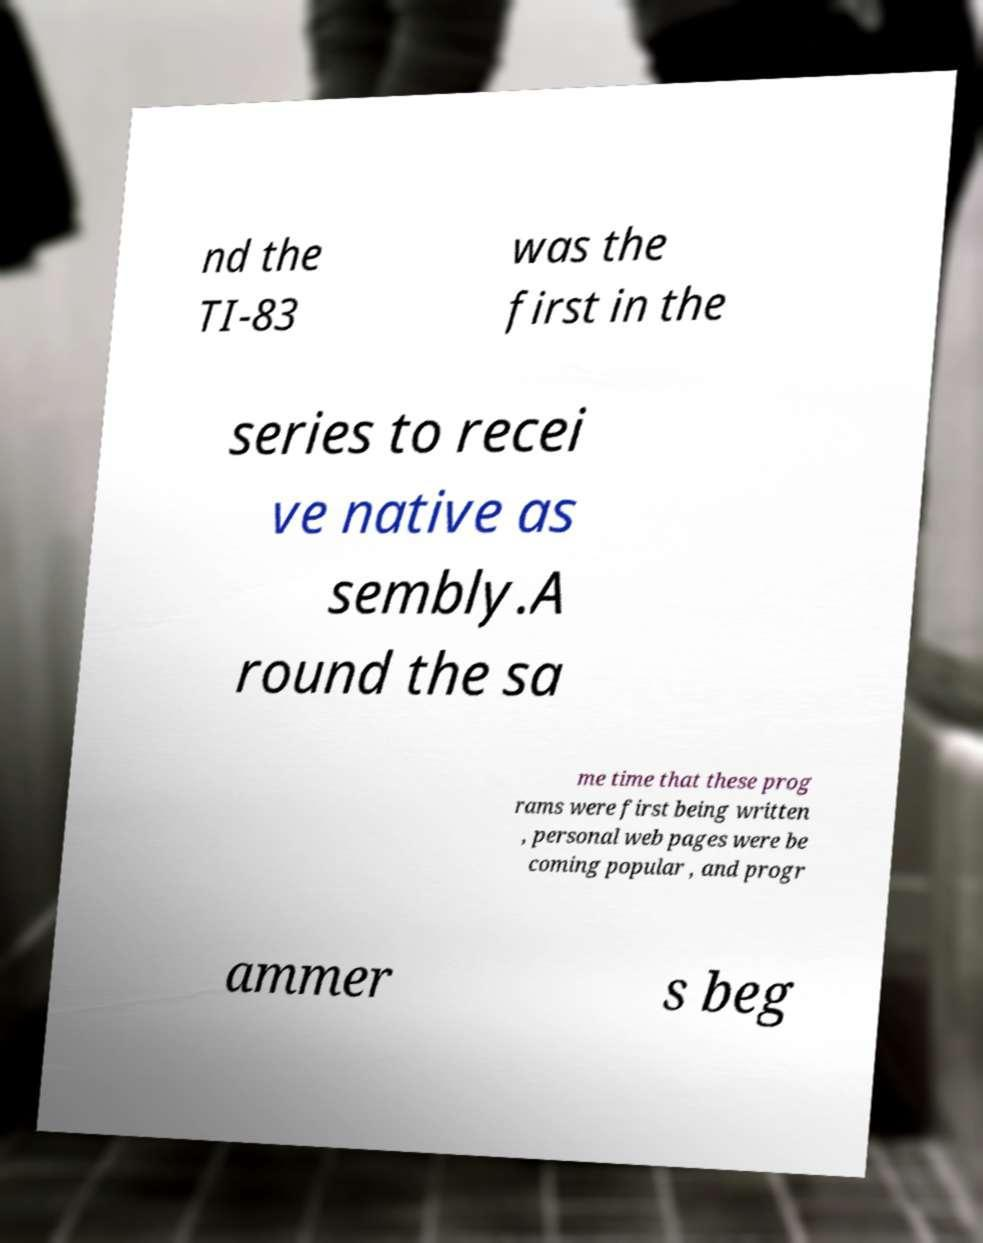There's text embedded in this image that I need extracted. Can you transcribe it verbatim? nd the TI-83 was the first in the series to recei ve native as sembly.A round the sa me time that these prog rams were first being written , personal web pages were be coming popular , and progr ammer s beg 